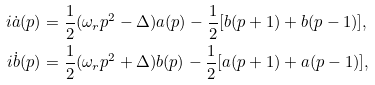Convert formula to latex. <formula><loc_0><loc_0><loc_500><loc_500>i \dot { a } ( p ) & = \frac { 1 } { 2 } ( \omega _ { r } p ^ { 2 } - \Delta ) a ( p ) - \frac { 1 } { 2 } [ b ( p + 1 ) + b ( p - 1 ) ] , \\ i \dot { b } ( p ) & = \frac { 1 } { 2 } ( \omega _ { r } p ^ { 2 } + \Delta ) b ( p ) - \frac { 1 } { 2 } [ a ( p + 1 ) + a ( p - 1 ) ] ,</formula> 